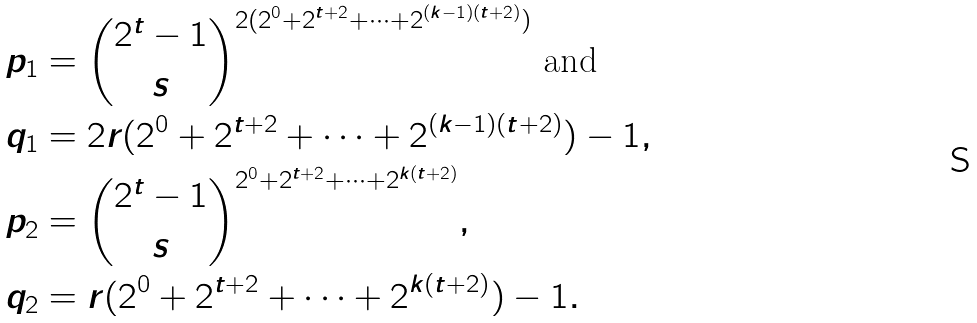<formula> <loc_0><loc_0><loc_500><loc_500>p _ { 1 } & = \binom { 2 ^ { t } - 1 } { s } ^ { 2 ( 2 ^ { 0 } + 2 ^ { t + 2 } + \dots + 2 ^ { ( k - 1 ) ( t + 2 ) } ) } \text { and } \\ q _ { 1 } & = 2 r ( 2 ^ { 0 } + 2 ^ { t + 2 } + \dots + 2 ^ { ( k - 1 ) ( t + 2 ) } ) - 1 , \\ p _ { 2 } & = \binom { 2 ^ { t } - 1 } { s } ^ { 2 ^ { 0 } + 2 ^ { t + 2 } + \dots + 2 ^ { k ( t + 2 ) } } , \\ q _ { 2 } & = r ( 2 ^ { 0 } + 2 ^ { t + 2 } + \dots + 2 ^ { k ( t + 2 ) } ) - 1 .</formula> 